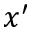<formula> <loc_0><loc_0><loc_500><loc_500>x ^ { \prime }</formula> 